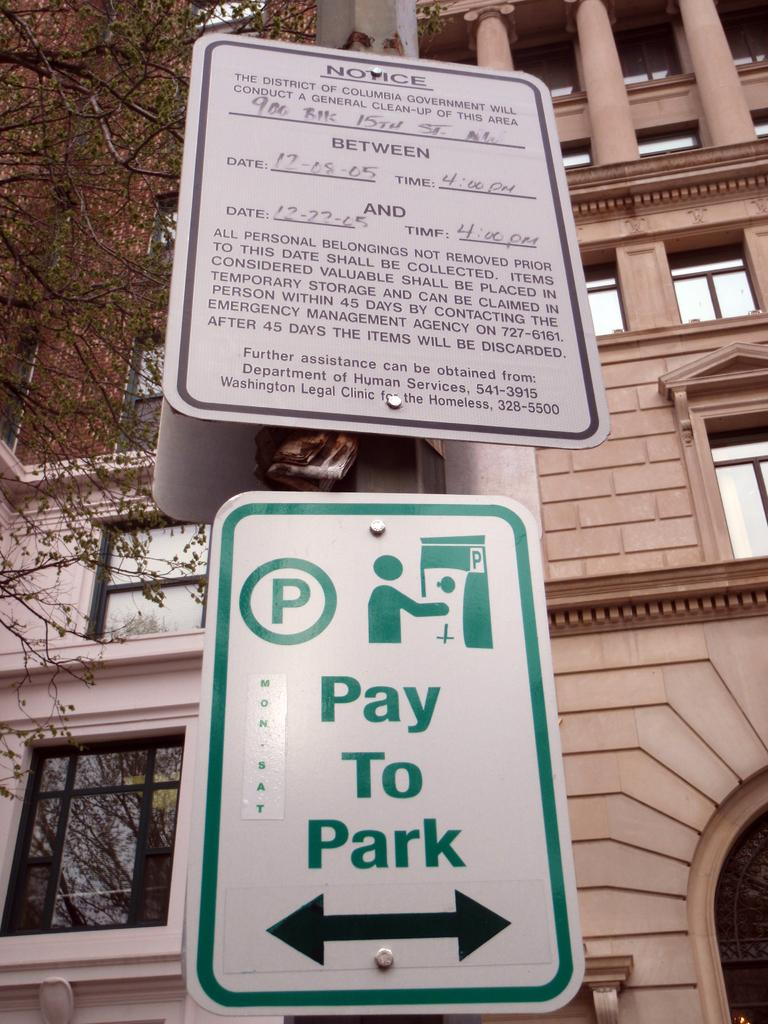<image>
Create a compact narrative representing the image presented. A green amd white sign that says Pay to Park. 